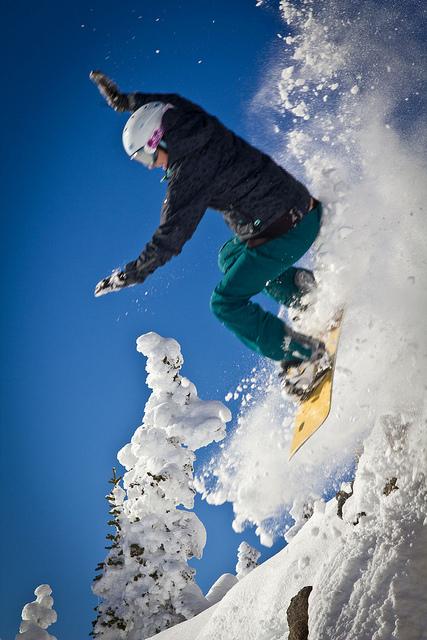What color are the man's pants?
Give a very brief answer. Green. What color is the snowboard?
Quick response, please. Yellow. Is this man snowboarding?
Answer briefly. Yes. What color is the man's helmet?
Give a very brief answer. White. 